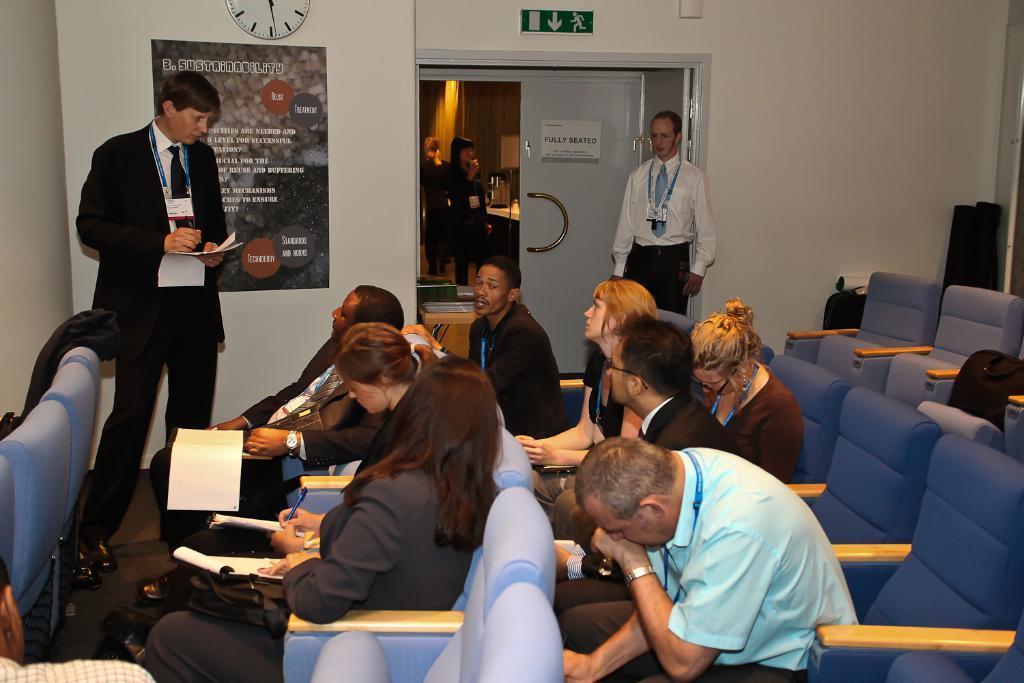How would you summarize this image in a sentence or two? In this image I can see number of persons are sitting on chairs which are blue in color. I can see few of them are holding books and pens in their hands. I can see few persons standing, the wall, the poster and a clock attached to the wall and the door through which I can see another person standing. 